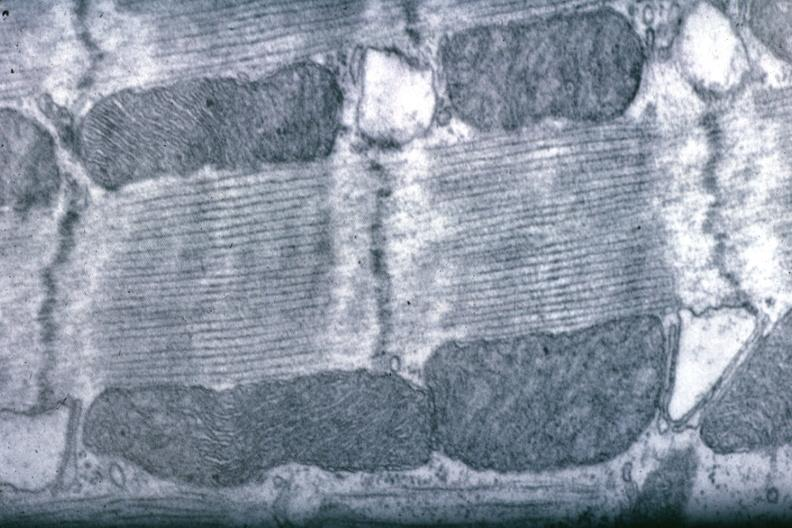where is this area in the body?
Answer the question using a single word or phrase. Heart 